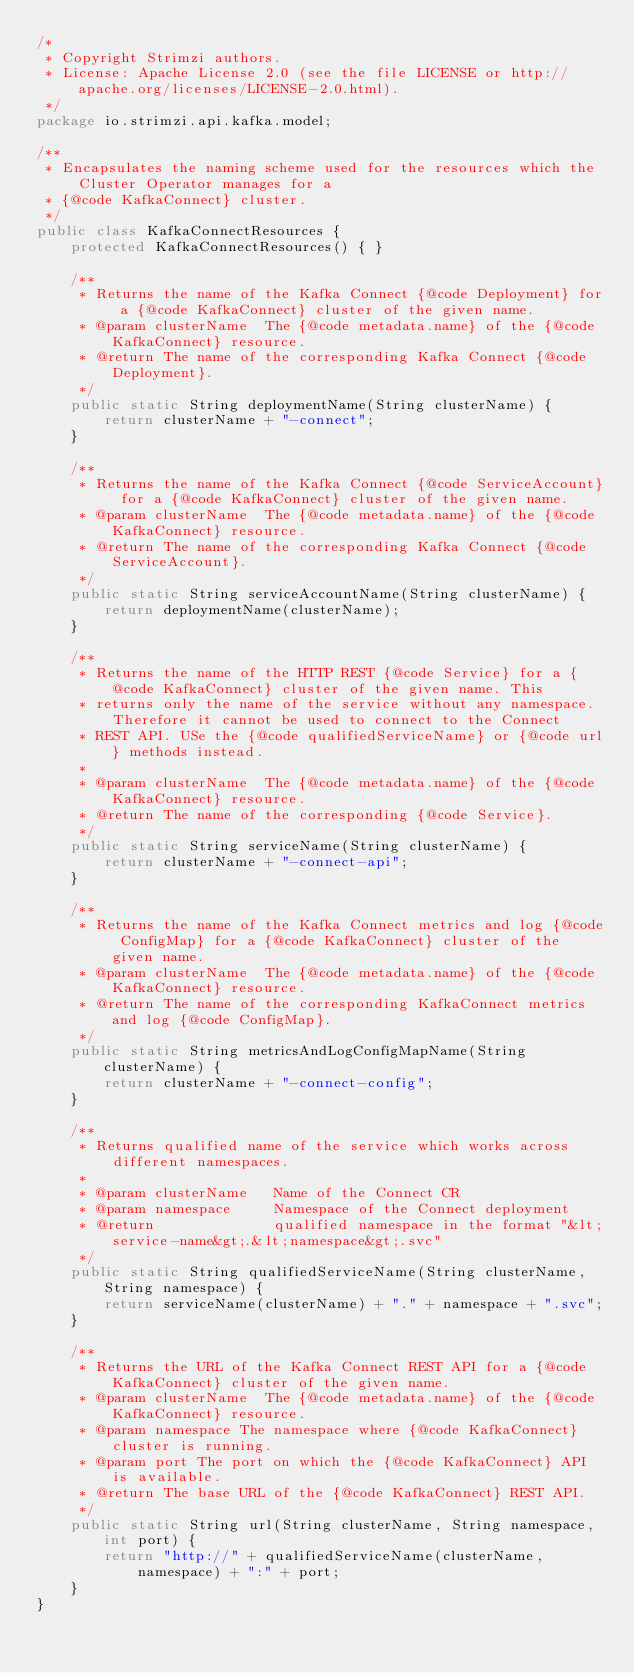Convert code to text. <code><loc_0><loc_0><loc_500><loc_500><_Java_>/*
 * Copyright Strimzi authors.
 * License: Apache License 2.0 (see the file LICENSE or http://apache.org/licenses/LICENSE-2.0.html).
 */
package io.strimzi.api.kafka.model;

/**
 * Encapsulates the naming scheme used for the resources which the Cluster Operator manages for a
 * {@code KafkaConnect} cluster.
 */
public class KafkaConnectResources {
    protected KafkaConnectResources() { }

    /**
     * Returns the name of the Kafka Connect {@code Deployment} for a {@code KafkaConnect} cluster of the given name.
     * @param clusterName  The {@code metadata.name} of the {@code KafkaConnect} resource.
     * @return The name of the corresponding Kafka Connect {@code Deployment}.
     */
    public static String deploymentName(String clusterName) {
        return clusterName + "-connect";
    }

    /**
     * Returns the name of the Kafka Connect {@code ServiceAccount} for a {@code KafkaConnect} cluster of the given name.
     * @param clusterName  The {@code metadata.name} of the {@code KafkaConnect} resource.
     * @return The name of the corresponding Kafka Connect {@code ServiceAccount}.
     */
    public static String serviceAccountName(String clusterName) {
        return deploymentName(clusterName);
    }

    /**
     * Returns the name of the HTTP REST {@code Service} for a {@code KafkaConnect} cluster of the given name. This
     * returns only the name of the service without any namespace. Therefore it cannot be used to connect to the Connect
     * REST API. USe the {@code qualifiedServiceName} or {@code url} methods instead.
     *
     * @param clusterName  The {@code metadata.name} of the {@code KafkaConnect} resource.
     * @return The name of the corresponding {@code Service}.
     */
    public static String serviceName(String clusterName) {
        return clusterName + "-connect-api";
    }

    /**
     * Returns the name of the Kafka Connect metrics and log {@code ConfigMap} for a {@code KafkaConnect} cluster of the given name.
     * @param clusterName  The {@code metadata.name} of the {@code KafkaConnect} resource.
     * @return The name of the corresponding KafkaConnect metrics and log {@code ConfigMap}.
     */
    public static String metricsAndLogConfigMapName(String clusterName) {
        return clusterName + "-connect-config";
    }

    /**
     * Returns qualified name of the service which works across different namespaces.
     *
     * @param clusterName   Name of the Connect CR
     * @param namespace     Namespace of the Connect deployment
     * @return              qualified namespace in the format "&lt;service-name&gt;.&lt;namespace&gt;.svc"
     */
    public static String qualifiedServiceName(String clusterName, String namespace) {
        return serviceName(clusterName) + "." + namespace + ".svc";
    }

    /**
     * Returns the URL of the Kafka Connect REST API for a {@code KafkaConnect} cluster of the given name.
     * @param clusterName  The {@code metadata.name} of the {@code KafkaConnect} resource.
     * @param namespace The namespace where {@code KafkaConnect} cluster is running.
     * @param port The port on which the {@code KafkaConnect} API is available.
     * @return The base URL of the {@code KafkaConnect} REST API.
     */
    public static String url(String clusterName, String namespace, int port) {
        return "http://" + qualifiedServiceName(clusterName, namespace) + ":" + port;
    }
}
</code> 